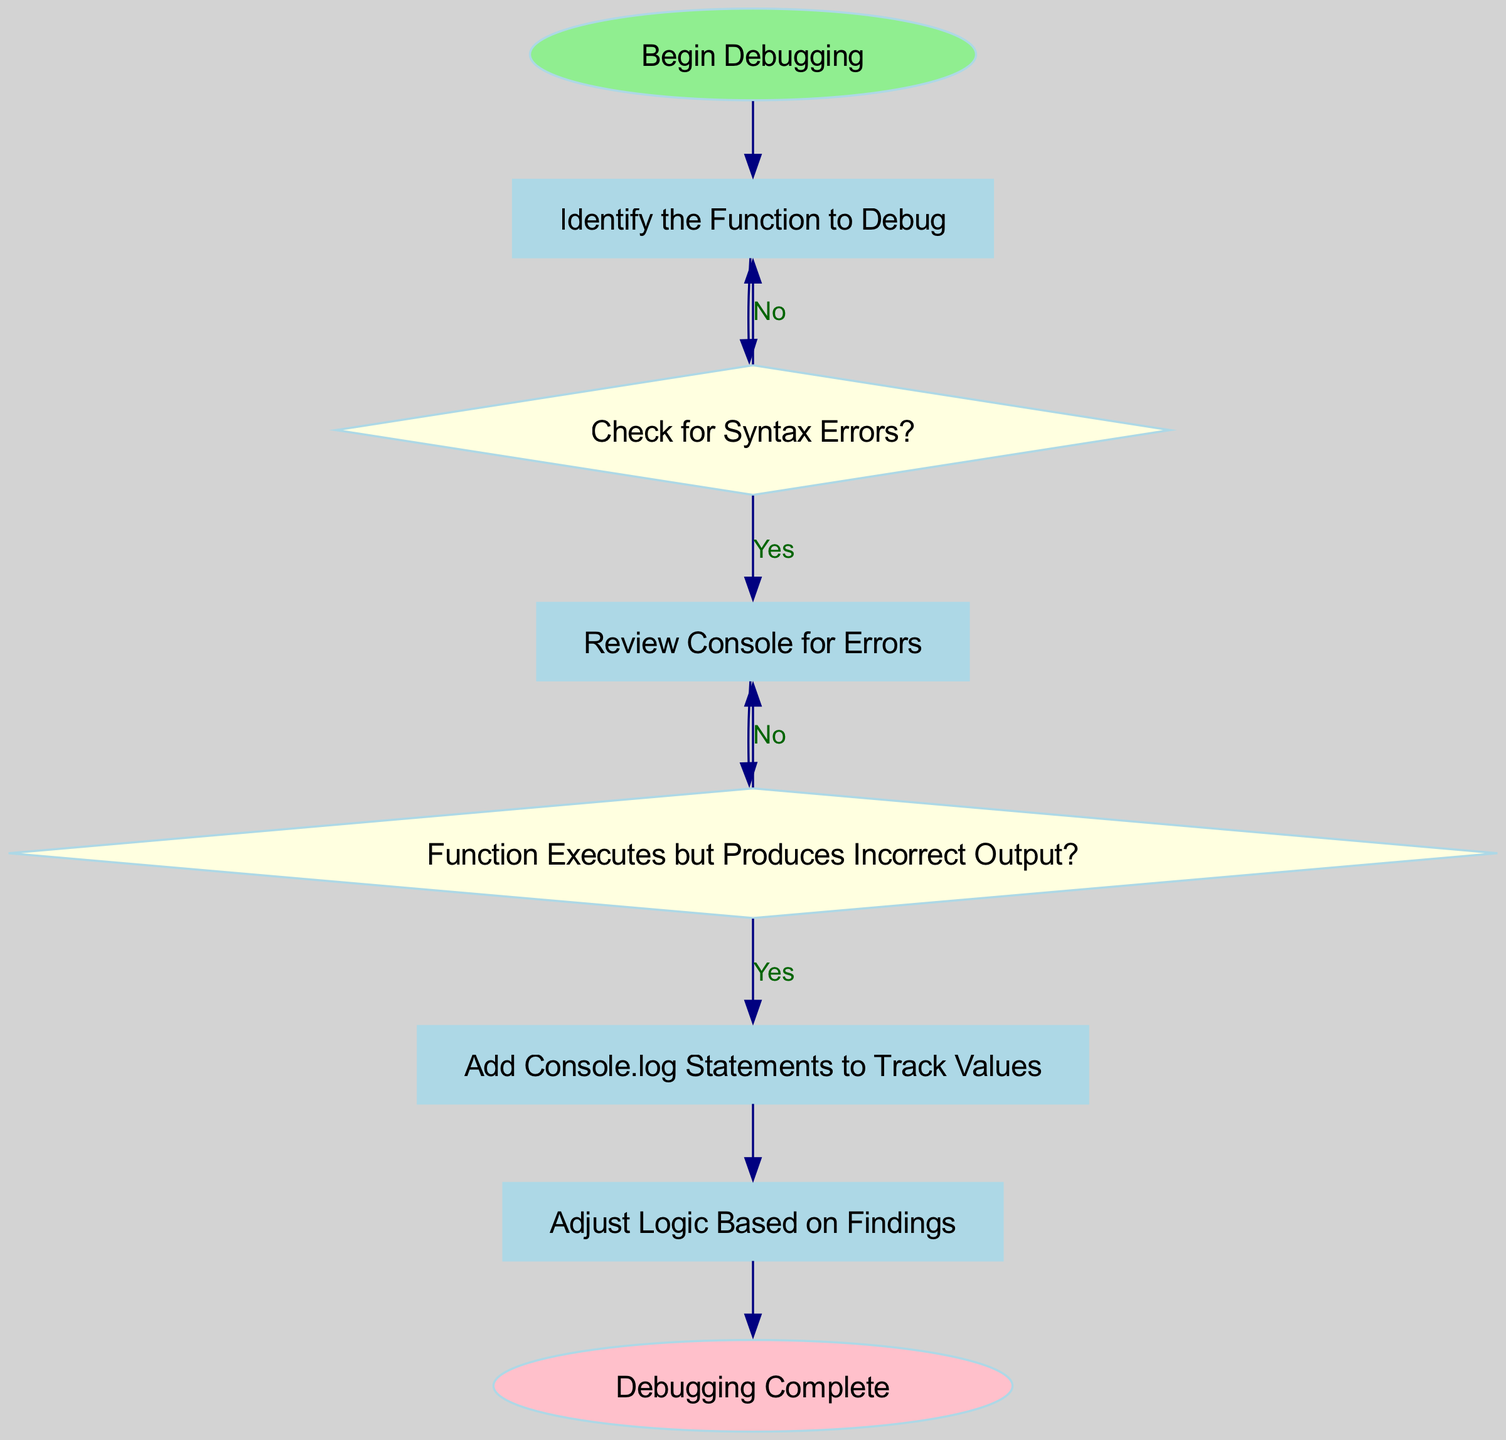What is the first step in the debugging process? The first step listed in the flow chart is "Begin Debugging." This is shown as the starting point of the diagram, indicated by the start node.
Answer: Begin Debugging How many decision nodes are in the flow chart? Upon examining the diagram, there are two decision nodes present: "Check for Syntax Errors?" and "Function Executes but Produces Incorrect Output?" Counting these leads to a total of two decision nodes.
Answer: Two What happens if there are syntax errors? According to the flow chart, if syntax errors are found, the process leads to the "Review Console for Errors" node, which is the next step in the flow.
Answer: Review Console for Errors What is the final step in the debugging process? The last step shown in the flow chart is "Debugging Complete." This is represented in the ending node at the end of the flow.
Answer: Debugging Complete What do you add to track values? The flow chart indicates that "Add Console.log Statements to Track Values" is the action to take when the function executes but produces incorrect output. This is a specific action taken in the debugging process.
Answer: Add Console.log Statements to Track Values If there are no syntax errors, what is the next question to answer? After checking for syntax errors and determining there are none, the next decision node to consider is "Function Executes but Produces Incorrect Output?" This follows logically from the flow of the diagram.
Answer: Function Executes but Produces Incorrect Output? 